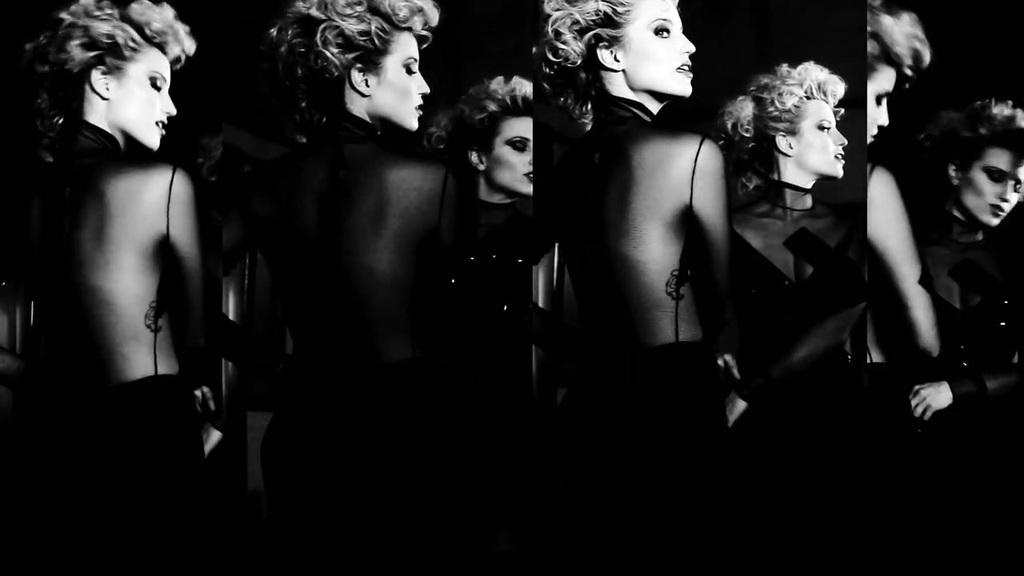What type of artwork is depicted in the image? The image is a collage. What subject is featured in the collage? The collage features a woman. What type of nut is visible in the image? There is no nut present in the image; it is a collage featuring a woman. Is there popcorn in the image? There is no popcorn present in the image; it is a collage featuring a woman. 